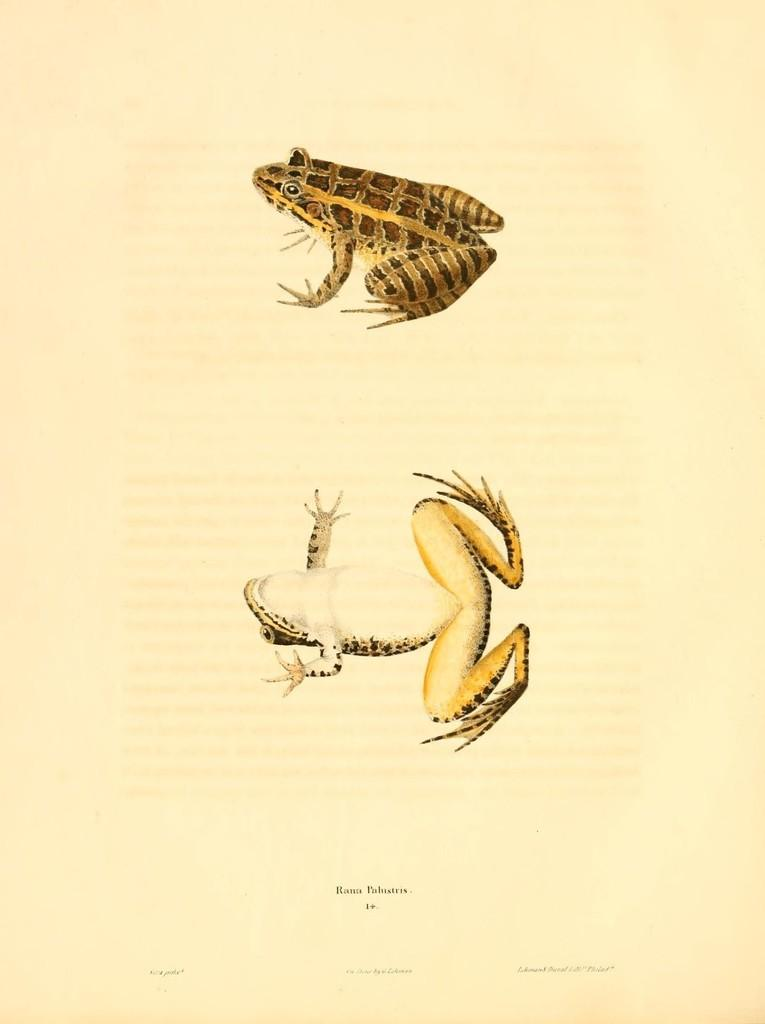What is featured on the poster in the image? There is a poster in the image, and it has two images of a frog. What else can be seen on the poster besides the frog images? There is text on the poster. What is the color of the background on the poster? The background of the poster is cream in color. What type of calendar is hanging next to the poster in the image? There is no calendar present in the image; it only features a poster with two images of a frog, text, and a cream-colored background. 